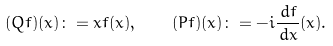Convert formula to latex. <formula><loc_0><loc_0><loc_500><loc_500>( Q f ) ( x ) \colon = x f ( x ) , \quad ( P f ) ( x ) \colon = - i \frac { \, d f } { \, d x } ( x ) .</formula> 